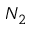<formula> <loc_0><loc_0><loc_500><loc_500>N _ { 2 }</formula> 